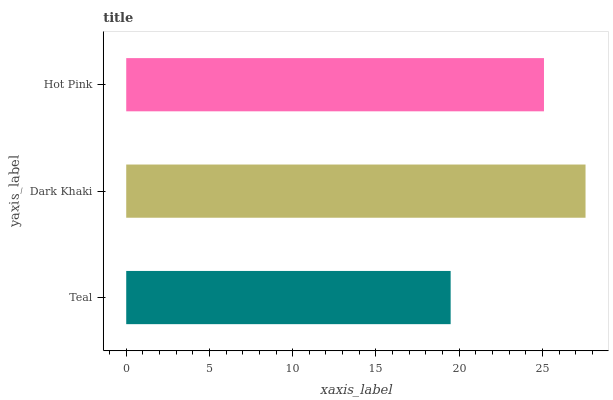Is Teal the minimum?
Answer yes or no. Yes. Is Dark Khaki the maximum?
Answer yes or no. Yes. Is Hot Pink the minimum?
Answer yes or no. No. Is Hot Pink the maximum?
Answer yes or no. No. Is Dark Khaki greater than Hot Pink?
Answer yes or no. Yes. Is Hot Pink less than Dark Khaki?
Answer yes or no. Yes. Is Hot Pink greater than Dark Khaki?
Answer yes or no. No. Is Dark Khaki less than Hot Pink?
Answer yes or no. No. Is Hot Pink the high median?
Answer yes or no. Yes. Is Hot Pink the low median?
Answer yes or no. Yes. Is Teal the high median?
Answer yes or no. No. Is Teal the low median?
Answer yes or no. No. 